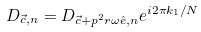<formula> <loc_0><loc_0><loc_500><loc_500>D _ { \vec { c } , n } = D _ { \vec { c } + p ^ { 2 } r \omega \hat { e } , n } e ^ { i 2 \pi k _ { 1 } / N }</formula> 